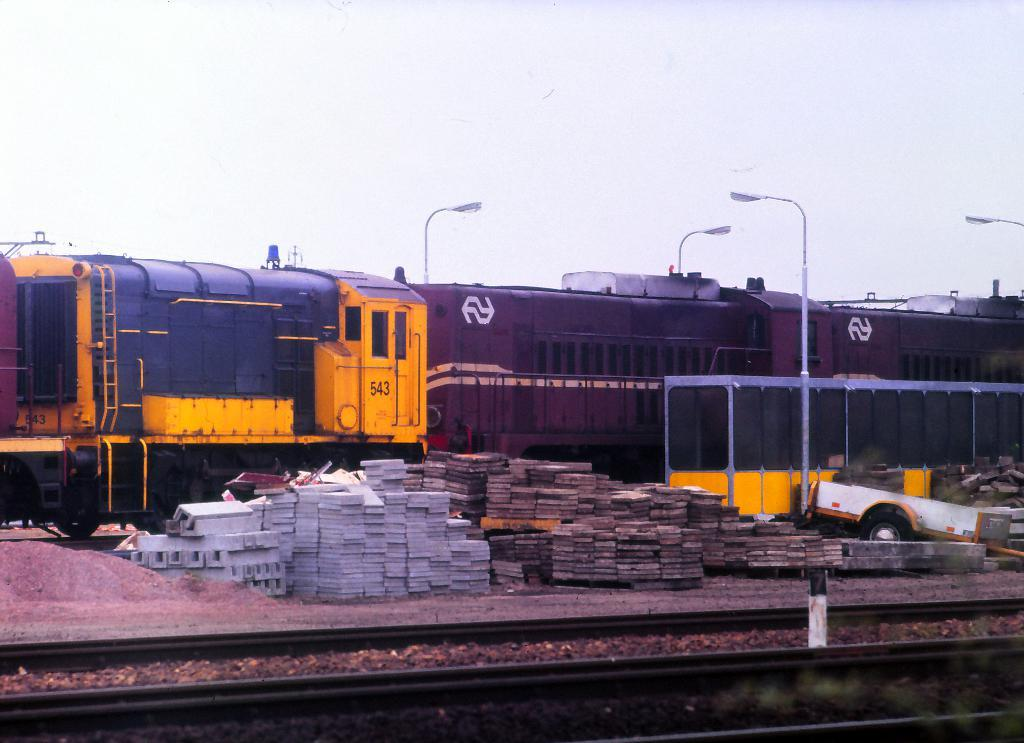What is the main subject of the image? The main subject of the image is a train. Where is the train located in the image? The train is on a track in the image. What other objects can be seen in the image? There are marbles, sand, a pole, and a fence visible in the image. What is visible in the background of the image? The sky is visible in the image. What type of furniture can be seen in the image? There is no furniture present in the image. What day of the week is depicted in the image? The image does not depict a specific day of the week. 